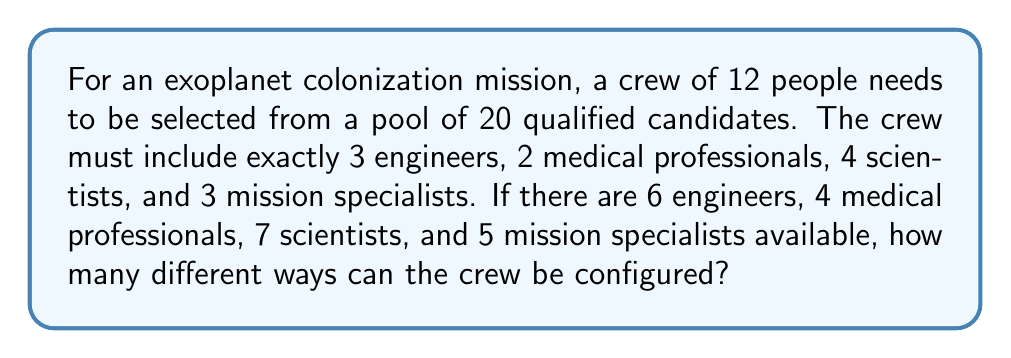Can you answer this question? Let's approach this step-by-step using the multiplication principle of counting:

1) For engineers: We need to choose 3 out of 6 available engineers.
   This can be done in $\binom{6}{3}$ ways.

2) For medical professionals: We need to choose 2 out of 4 available medical professionals.
   This can be done in $\binom{4}{2}$ ways.

3) For scientists: We need to choose 4 out of 7 available scientists.
   This can be done in $\binom{7}{4}$ ways.

4) For mission specialists: We need to choose 3 out of 5 available mission specialists.
   This can be done in $\binom{5}{3}$ ways.

Now, let's calculate each combination:

$\binom{6}{3} = \frac{6!}{3!(6-3)!} = \frac{6!}{3!3!} = 20$

$\binom{4}{2} = \frac{4!}{2!(4-2)!} = \frac{4!}{2!2!} = 6$

$\binom{7}{4} = \frac{7!}{4!(7-4)!} = \frac{7!}{4!3!} = 35$

$\binom{5}{3} = \frac{5!}{3!(5-3)!} = \frac{5!}{3!2!} = 10$

By the multiplication principle, the total number of ways to configure the crew is the product of these individual combinations:

$20 \times 6 \times 35 \times 10 = 42,000$
Answer: 42,000 